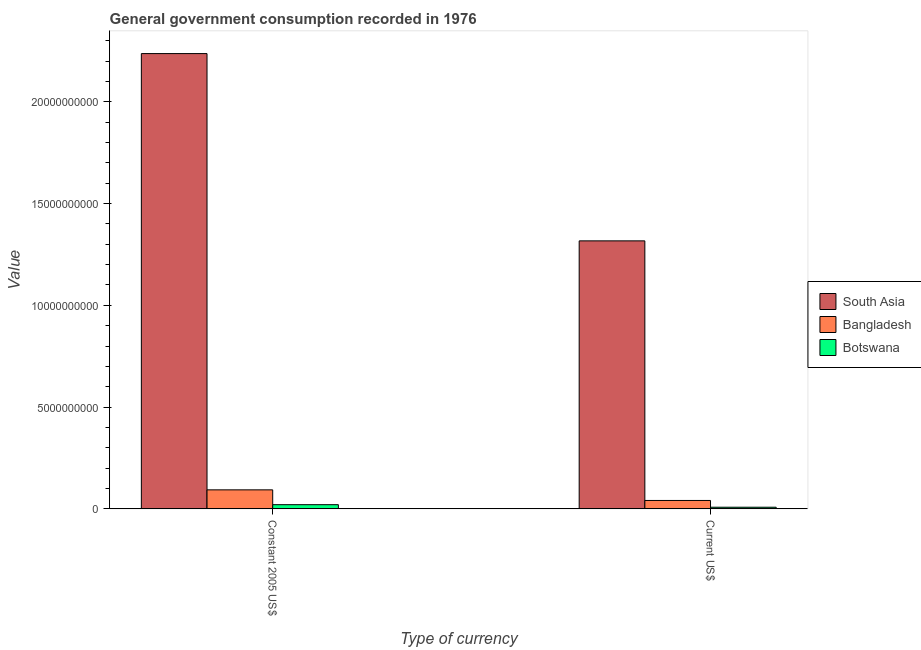How many groups of bars are there?
Your answer should be compact. 2. How many bars are there on the 2nd tick from the left?
Ensure brevity in your answer.  3. How many bars are there on the 1st tick from the right?
Your answer should be compact. 3. What is the label of the 2nd group of bars from the left?
Offer a very short reply. Current US$. What is the value consumed in current us$ in South Asia?
Make the answer very short. 1.32e+1. Across all countries, what is the maximum value consumed in current us$?
Keep it short and to the point. 1.32e+1. Across all countries, what is the minimum value consumed in current us$?
Provide a succinct answer. 7.96e+07. In which country was the value consumed in constant 2005 us$ maximum?
Make the answer very short. South Asia. In which country was the value consumed in constant 2005 us$ minimum?
Provide a short and direct response. Botswana. What is the total value consumed in constant 2005 us$ in the graph?
Ensure brevity in your answer.  2.35e+1. What is the difference between the value consumed in current us$ in Bangladesh and that in Botswana?
Give a very brief answer. 3.32e+08. What is the difference between the value consumed in constant 2005 us$ in Botswana and the value consumed in current us$ in Bangladesh?
Provide a short and direct response. -2.07e+08. What is the average value consumed in current us$ per country?
Ensure brevity in your answer.  4.55e+09. What is the difference between the value consumed in current us$ and value consumed in constant 2005 us$ in Bangladesh?
Offer a terse response. -5.22e+08. What is the ratio of the value consumed in constant 2005 us$ in South Asia to that in Botswana?
Keep it short and to the point. 109.24. What does the 3rd bar from the left in Constant 2005 US$ represents?
Give a very brief answer. Botswana. How many bars are there?
Offer a terse response. 6. What is the difference between two consecutive major ticks on the Y-axis?
Offer a terse response. 5.00e+09. What is the title of the graph?
Your response must be concise. General government consumption recorded in 1976. What is the label or title of the X-axis?
Your answer should be very brief. Type of currency. What is the label or title of the Y-axis?
Ensure brevity in your answer.  Value. What is the Value of South Asia in Constant 2005 US$?
Provide a succinct answer. 2.24e+1. What is the Value of Bangladesh in Constant 2005 US$?
Provide a short and direct response. 9.33e+08. What is the Value of Botswana in Constant 2005 US$?
Make the answer very short. 2.05e+08. What is the Value in South Asia in Current US$?
Give a very brief answer. 1.32e+1. What is the Value in Bangladesh in Current US$?
Your answer should be compact. 4.12e+08. What is the Value of Botswana in Current US$?
Make the answer very short. 7.96e+07. Across all Type of currency, what is the maximum Value of South Asia?
Offer a very short reply. 2.24e+1. Across all Type of currency, what is the maximum Value of Bangladesh?
Provide a short and direct response. 9.33e+08. Across all Type of currency, what is the maximum Value in Botswana?
Your answer should be compact. 2.05e+08. Across all Type of currency, what is the minimum Value of South Asia?
Offer a terse response. 1.32e+1. Across all Type of currency, what is the minimum Value of Bangladesh?
Ensure brevity in your answer.  4.12e+08. Across all Type of currency, what is the minimum Value in Botswana?
Your response must be concise. 7.96e+07. What is the total Value of South Asia in the graph?
Your response must be concise. 3.55e+1. What is the total Value of Bangladesh in the graph?
Keep it short and to the point. 1.34e+09. What is the total Value in Botswana in the graph?
Your answer should be compact. 2.84e+08. What is the difference between the Value in South Asia in Constant 2005 US$ and that in Current US$?
Provide a succinct answer. 9.20e+09. What is the difference between the Value of Bangladesh in Constant 2005 US$ and that in Current US$?
Offer a very short reply. 5.22e+08. What is the difference between the Value in Botswana in Constant 2005 US$ and that in Current US$?
Offer a very short reply. 1.25e+08. What is the difference between the Value of South Asia in Constant 2005 US$ and the Value of Bangladesh in Current US$?
Keep it short and to the point. 2.20e+1. What is the difference between the Value in South Asia in Constant 2005 US$ and the Value in Botswana in Current US$?
Make the answer very short. 2.23e+1. What is the difference between the Value of Bangladesh in Constant 2005 US$ and the Value of Botswana in Current US$?
Your answer should be very brief. 8.54e+08. What is the average Value in South Asia per Type of currency?
Your answer should be very brief. 1.78e+1. What is the average Value in Bangladesh per Type of currency?
Ensure brevity in your answer.  6.72e+08. What is the average Value in Botswana per Type of currency?
Offer a very short reply. 1.42e+08. What is the difference between the Value in South Asia and Value in Bangladesh in Constant 2005 US$?
Make the answer very short. 2.14e+1. What is the difference between the Value in South Asia and Value in Botswana in Constant 2005 US$?
Ensure brevity in your answer.  2.22e+1. What is the difference between the Value of Bangladesh and Value of Botswana in Constant 2005 US$?
Keep it short and to the point. 7.28e+08. What is the difference between the Value of South Asia and Value of Bangladesh in Current US$?
Provide a succinct answer. 1.28e+1. What is the difference between the Value of South Asia and Value of Botswana in Current US$?
Keep it short and to the point. 1.31e+1. What is the difference between the Value of Bangladesh and Value of Botswana in Current US$?
Your answer should be compact. 3.32e+08. What is the ratio of the Value in South Asia in Constant 2005 US$ to that in Current US$?
Provide a succinct answer. 1.7. What is the ratio of the Value of Bangladesh in Constant 2005 US$ to that in Current US$?
Your answer should be very brief. 2.27. What is the ratio of the Value of Botswana in Constant 2005 US$ to that in Current US$?
Ensure brevity in your answer.  2.57. What is the difference between the highest and the second highest Value in South Asia?
Provide a short and direct response. 9.20e+09. What is the difference between the highest and the second highest Value in Bangladesh?
Your answer should be compact. 5.22e+08. What is the difference between the highest and the second highest Value of Botswana?
Give a very brief answer. 1.25e+08. What is the difference between the highest and the lowest Value in South Asia?
Give a very brief answer. 9.20e+09. What is the difference between the highest and the lowest Value of Bangladesh?
Give a very brief answer. 5.22e+08. What is the difference between the highest and the lowest Value in Botswana?
Offer a very short reply. 1.25e+08. 